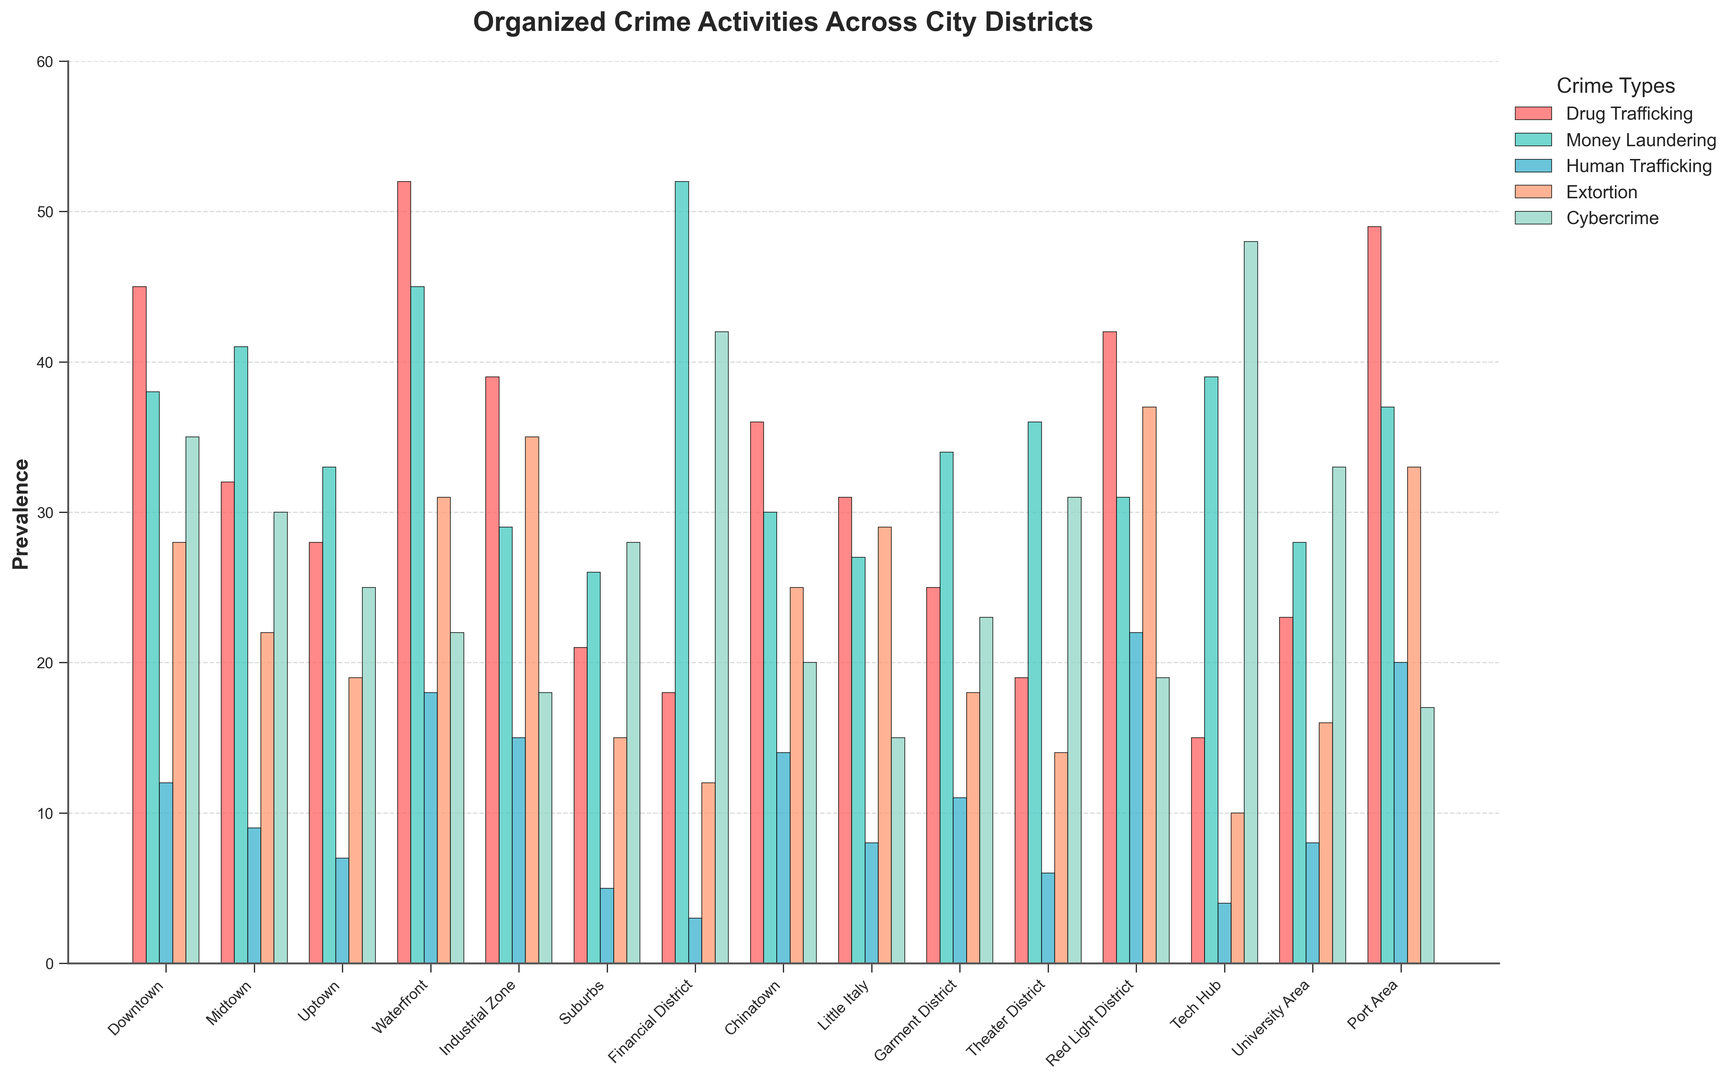What is the prevalence of drug trafficking in the Red Light District compared to the Financial District? The bar representing drug trafficking in the Red Light District is higher than the one for the Financial District. The exact values are 42 (Red Light District) and 18 (Financial District).
Answer: Red Light District has higher prevalence Which district has the highest number of money laundering activities? The district with the tallest bar for money laundering activities is the Financial District.
Answer: Financial District What is the total prevalence of human trafficking across all districts? Adding up the values for human trafficking across all districts: 12 (Downtown) + 9 (Midtown) + 7 (Uptown) + 18 (Waterfront) + 15 (Industrial Zone) + 5 (Suburbs) + 3 (Financial District) + 14 (Chinatown) + 8 (Little Italy) + 11 (Garment District) + 6 (Theater District) + 22 (Red Light District) + 4 (Tech Hub) + 8 (University Area) + 20 (Port Area) = 162
Answer: 162 Which district has the lowest prevalence of cybercrime? The district with the shortest bar for cybercrime activities is Little Italy.
Answer: Little Italy How much more prevalent is extortion in the Industrial Zone compared to the University Area? The prevalence of extortion in the Industrial Zone is 35, while in the University Area, it is 16. The difference is 35 - 16 = 19.
Answer: 19 Comparing Downtown and Theater District, which has a higher total prevalence of organized crime activities, and by how much? Downtown has a total prevalence of 45 (Drug Trafficking) + 38 (Money Laundering) + 12 (Human Trafficking) + 28 (Extortion) + 35 (Cybercrime) = 158. Theater District has a total of 19 (Drug Trafficking) + 36 (Money Laundering) + 6 (Human Trafficking) + 14 (Extortion) + 31 (Cybercrime) = 106. The difference is 158 - 106 = 52.
Answer: Downtown by 52 Which district has almost equal prevalence of drug trafficking and cybercrime? The district where the bars of drug trafficking and cybercrime are nearly equal is Tech Hub, with drug trafficking at 15 and cybercrime at 48.
Answer: Tech Hub What is the average prevalence of extortion across the Theater District, Red Light District, and Tech Hub? The values of extortion for these districts are 14 (Theater District), 37 (Red Light District), and 10 (Tech Hub). The sum is 14 + 37 + 10 = 61. The average is 61 / 3 = 20.33
Answer: 20.33 